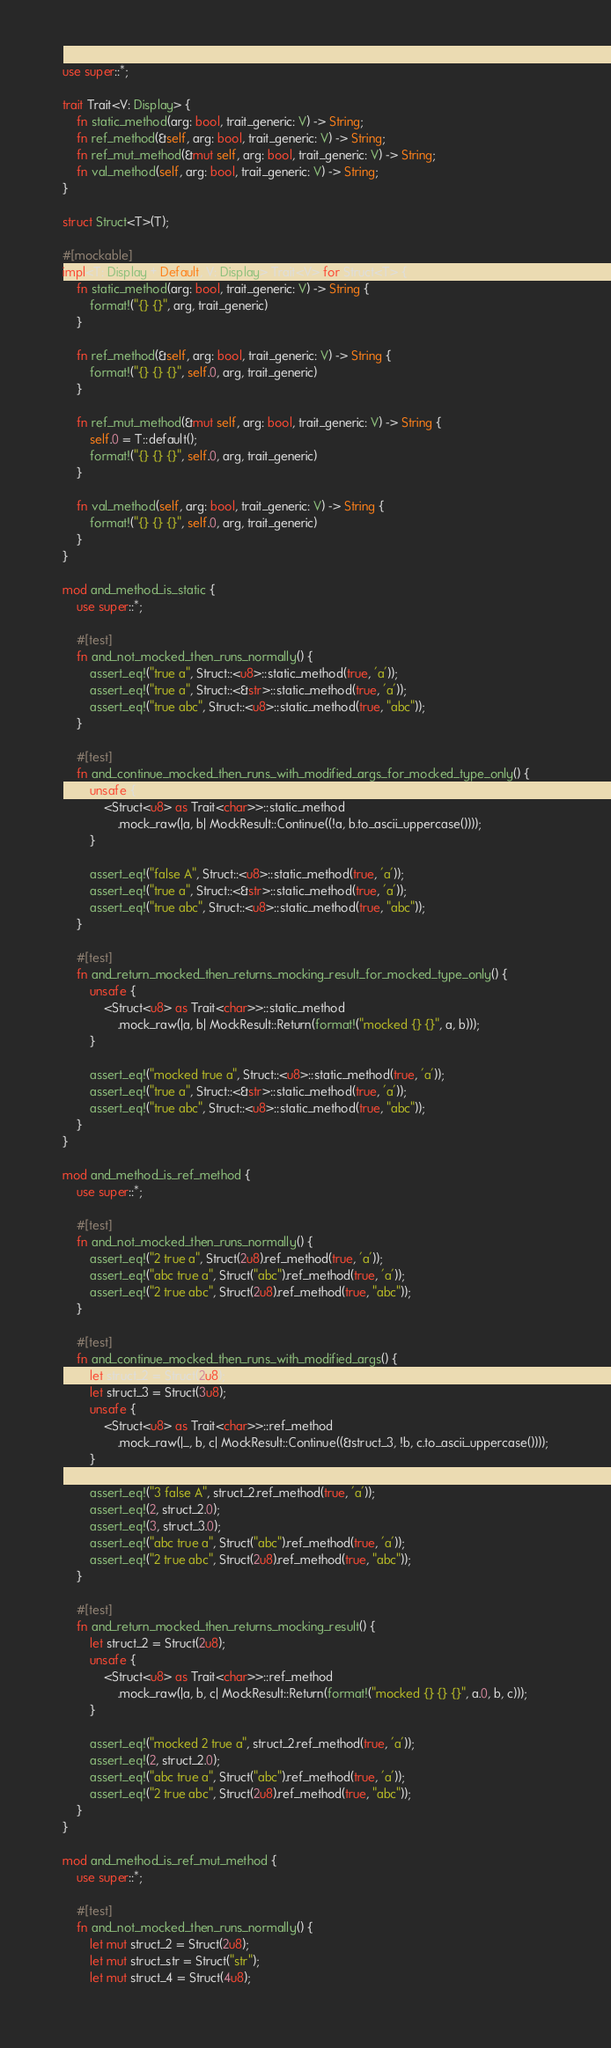<code> <loc_0><loc_0><loc_500><loc_500><_Rust_>use super::*;

trait Trait<V: Display> {
    fn static_method(arg: bool, trait_generic: V) -> String;
    fn ref_method(&self, arg: bool, trait_generic: V) -> String;
    fn ref_mut_method(&mut self, arg: bool, trait_generic: V) -> String;
    fn val_method(self, arg: bool, trait_generic: V) -> String;
}

struct Struct<T>(T);

#[mockable]
impl<T: Display + Default, V: Display> Trait<V> for Struct<T> {
    fn static_method(arg: bool, trait_generic: V) -> String {
        format!("{} {}", arg, trait_generic)
    }

    fn ref_method(&self, arg: bool, trait_generic: V) -> String {
        format!("{} {} {}", self.0, arg, trait_generic)
    }

    fn ref_mut_method(&mut self, arg: bool, trait_generic: V) -> String {
        self.0 = T::default();
        format!("{} {} {}", self.0, arg, trait_generic)
    }

    fn val_method(self, arg: bool, trait_generic: V) -> String {
        format!("{} {} {}", self.0, arg, trait_generic)
    }
}

mod and_method_is_static {
    use super::*;

    #[test]
    fn and_not_mocked_then_runs_normally() {
        assert_eq!("true a", Struct::<u8>::static_method(true, 'a'));
        assert_eq!("true a", Struct::<&str>::static_method(true, 'a'));
        assert_eq!("true abc", Struct::<u8>::static_method(true, "abc"));
    }

    #[test]
    fn and_continue_mocked_then_runs_with_modified_args_for_mocked_type_only() {
        unsafe {
            <Struct<u8> as Trait<char>>::static_method
                .mock_raw(|a, b| MockResult::Continue((!a, b.to_ascii_uppercase())));
        }

        assert_eq!("false A", Struct::<u8>::static_method(true, 'a'));
        assert_eq!("true a", Struct::<&str>::static_method(true, 'a'));
        assert_eq!("true abc", Struct::<u8>::static_method(true, "abc"));
    }

    #[test]
    fn and_return_mocked_then_returns_mocking_result_for_mocked_type_only() {
        unsafe {
            <Struct<u8> as Trait<char>>::static_method
                .mock_raw(|a, b| MockResult::Return(format!("mocked {} {}", a, b)));
        }

        assert_eq!("mocked true a", Struct::<u8>::static_method(true, 'a'));
        assert_eq!("true a", Struct::<&str>::static_method(true, 'a'));
        assert_eq!("true abc", Struct::<u8>::static_method(true, "abc"));
    }
}

mod and_method_is_ref_method {
    use super::*;

    #[test]
    fn and_not_mocked_then_runs_normally() {
        assert_eq!("2 true a", Struct(2u8).ref_method(true, 'a'));
        assert_eq!("abc true a", Struct("abc").ref_method(true, 'a'));
        assert_eq!("2 true abc", Struct(2u8).ref_method(true, "abc"));
    }

    #[test]
    fn and_continue_mocked_then_runs_with_modified_args() {
        let struct_2 = Struct(2u8);
        let struct_3 = Struct(3u8);
        unsafe {
            <Struct<u8> as Trait<char>>::ref_method
                .mock_raw(|_, b, c| MockResult::Continue((&struct_3, !b, c.to_ascii_uppercase())));
        }

        assert_eq!("3 false A", struct_2.ref_method(true, 'a'));
        assert_eq!(2, struct_2.0);
        assert_eq!(3, struct_3.0);
        assert_eq!("abc true a", Struct("abc").ref_method(true, 'a'));
        assert_eq!("2 true abc", Struct(2u8).ref_method(true, "abc"));
    }

    #[test]
    fn and_return_mocked_then_returns_mocking_result() {
        let struct_2 = Struct(2u8);
        unsafe {
            <Struct<u8> as Trait<char>>::ref_method
                .mock_raw(|a, b, c| MockResult::Return(format!("mocked {} {} {}", a.0, b, c)));
        }

        assert_eq!("mocked 2 true a", struct_2.ref_method(true, 'a'));
        assert_eq!(2, struct_2.0);
        assert_eq!("abc true a", Struct("abc").ref_method(true, 'a'));
        assert_eq!("2 true abc", Struct(2u8).ref_method(true, "abc"));
    }
}

mod and_method_is_ref_mut_method {
    use super::*;

    #[test]
    fn and_not_mocked_then_runs_normally() {
        let mut struct_2 = Struct(2u8);
        let mut struct_str = Struct("str");
        let mut struct_4 = Struct(4u8);
</code> 